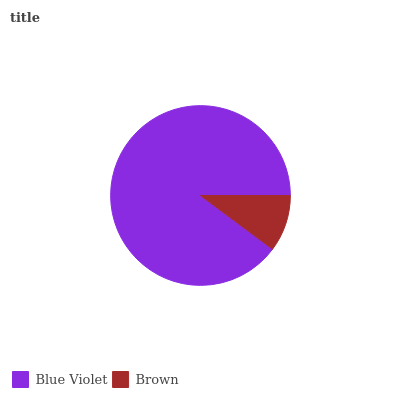Is Brown the minimum?
Answer yes or no. Yes. Is Blue Violet the maximum?
Answer yes or no. Yes. Is Brown the maximum?
Answer yes or no. No. Is Blue Violet greater than Brown?
Answer yes or no. Yes. Is Brown less than Blue Violet?
Answer yes or no. Yes. Is Brown greater than Blue Violet?
Answer yes or no. No. Is Blue Violet less than Brown?
Answer yes or no. No. Is Blue Violet the high median?
Answer yes or no. Yes. Is Brown the low median?
Answer yes or no. Yes. Is Brown the high median?
Answer yes or no. No. Is Blue Violet the low median?
Answer yes or no. No. 